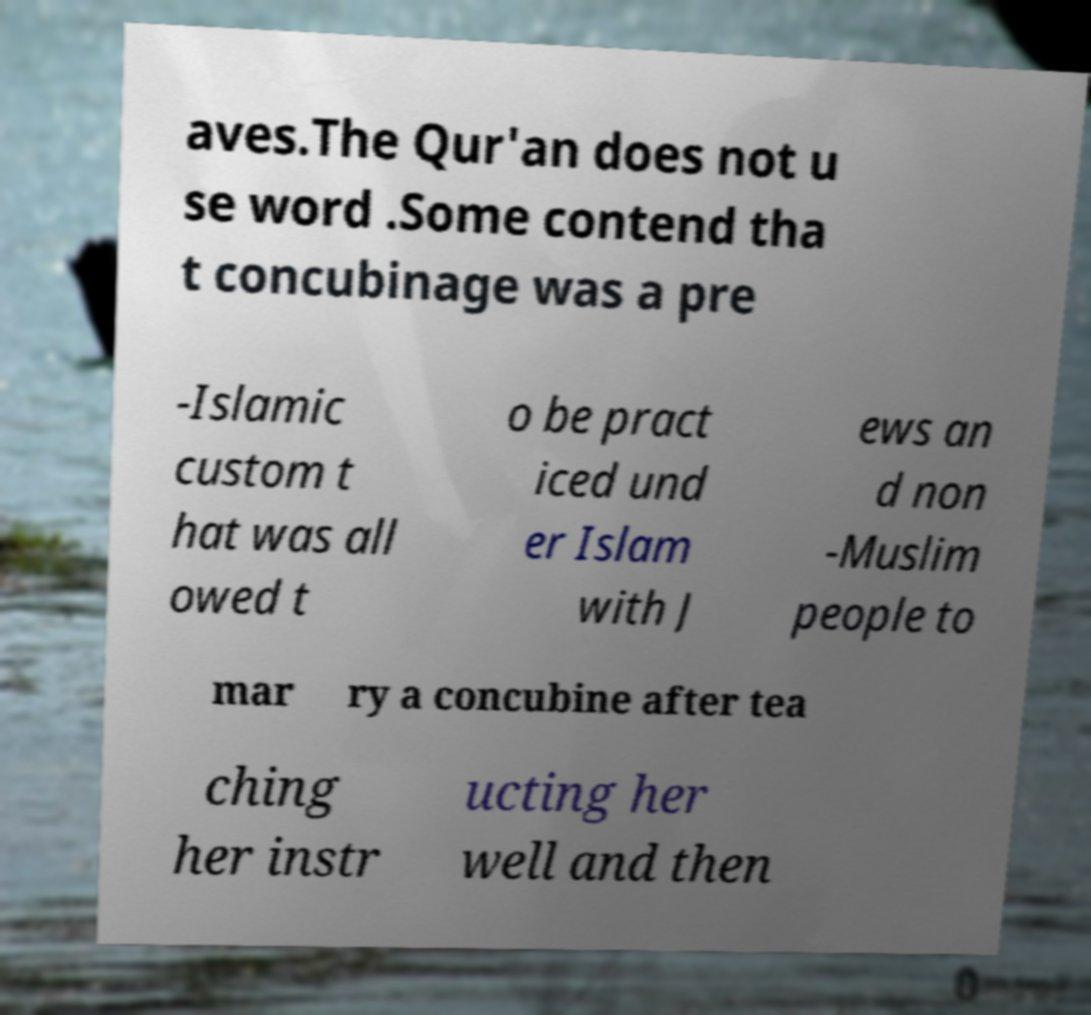Please identify and transcribe the text found in this image. aves.The Qur'an does not u se word .Some contend tha t concubinage was a pre -Islamic custom t hat was all owed t o be pract iced und er Islam with J ews an d non -Muslim people to mar ry a concubine after tea ching her instr ucting her well and then 